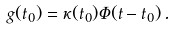Convert formula to latex. <formula><loc_0><loc_0><loc_500><loc_500>g ( t _ { 0 } ) = \kappa ( t _ { 0 } ) \Phi ( t - t _ { 0 } ) \, .</formula> 